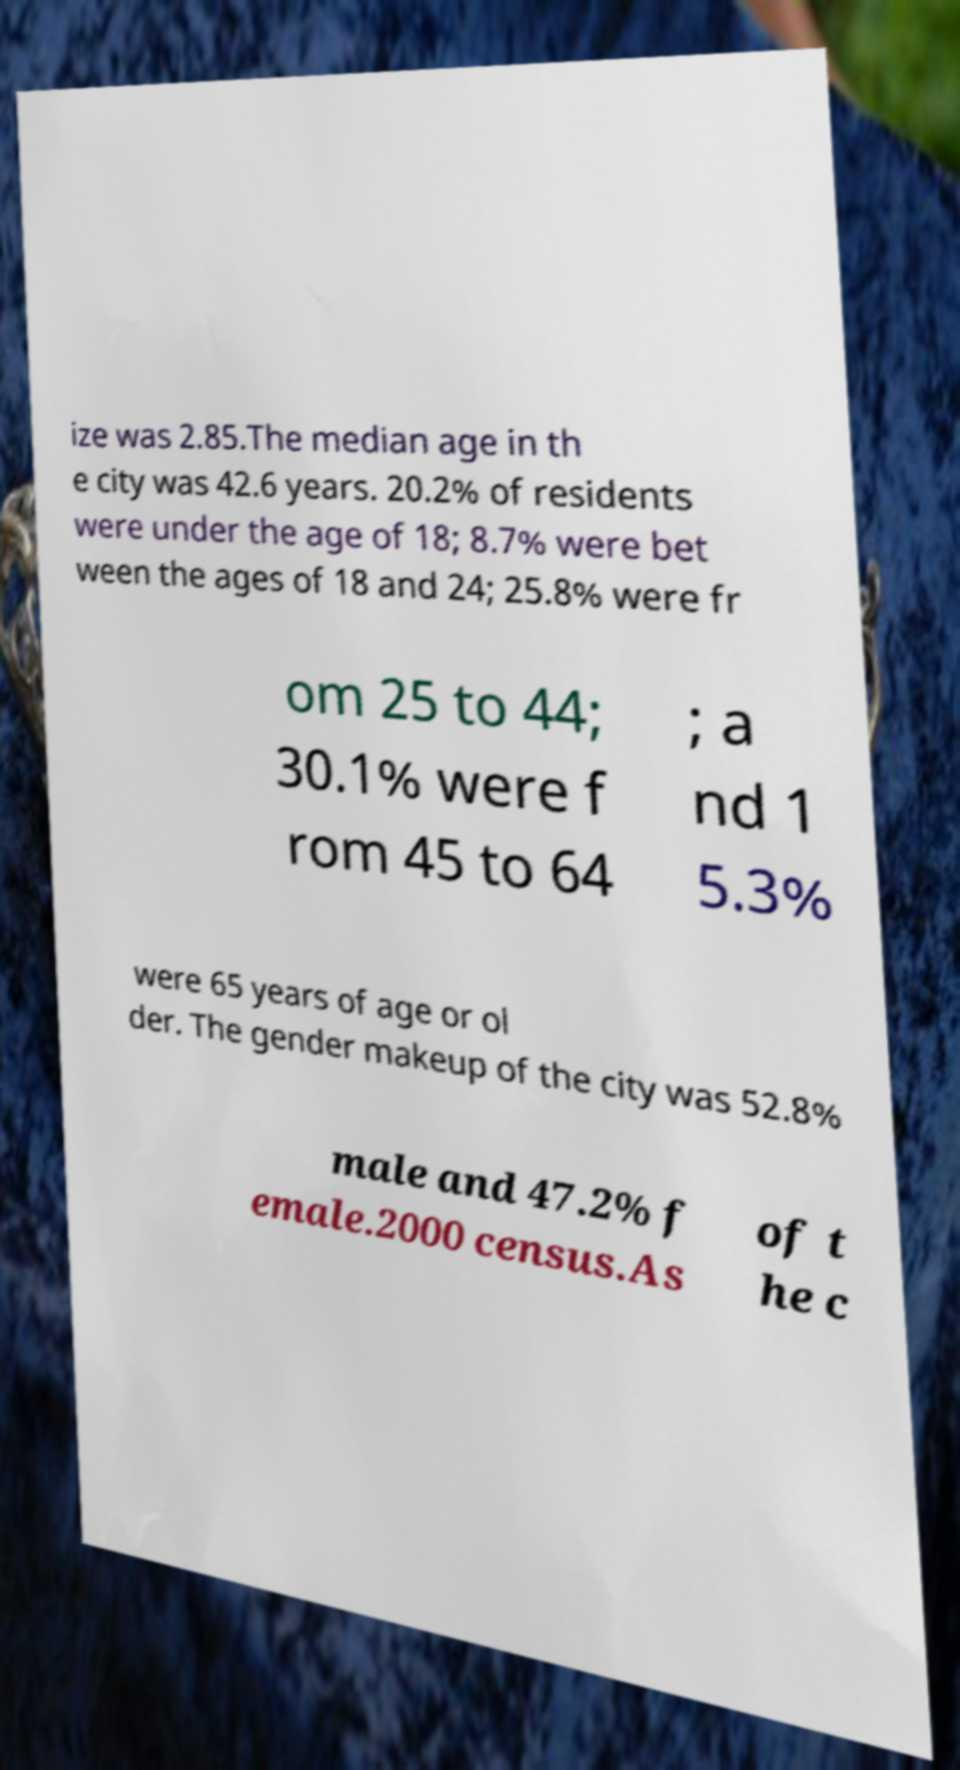I need the written content from this picture converted into text. Can you do that? ize was 2.85.The median age in th e city was 42.6 years. 20.2% of residents were under the age of 18; 8.7% were bet ween the ages of 18 and 24; 25.8% were fr om 25 to 44; 30.1% were f rom 45 to 64 ; a nd 1 5.3% were 65 years of age or ol der. The gender makeup of the city was 52.8% male and 47.2% f emale.2000 census.As of t he c 